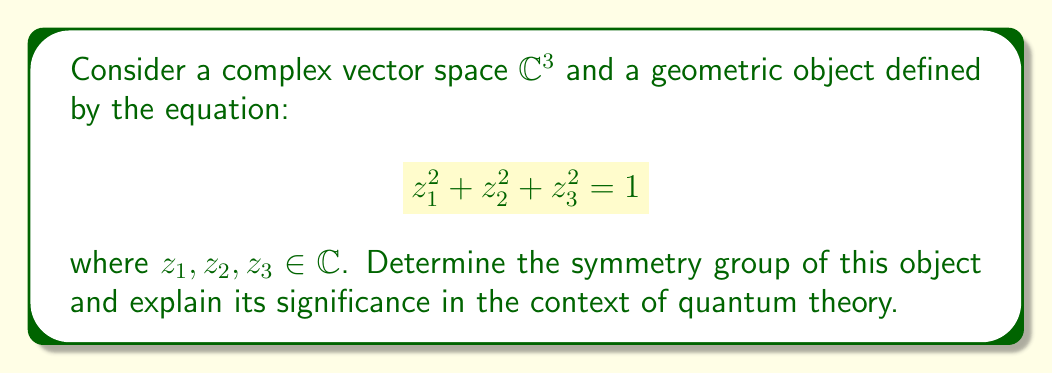Teach me how to tackle this problem. 1. Identify the equation:
   The equation $z_1^2 + z_2^2 + z_3^2 = 1$ defines a complex 2-sphere in $\mathbb{C}^3$.

2. Analyze symmetries:
   a) Rotational symmetry: The equation is invariant under rotations in $\mathbb{C}^3$, represented by the special orthogonal group $SO(3, \mathbb{C})$.
   b) Reflection symmetry: The equation is also invariant under reflections, which together with rotations form the orthogonal group $O(3, \mathbb{C})$.

3. Identify the symmetry group:
   The full symmetry group is $O(3, \mathbb{C})$.

4. Quantum theory connection:
   a) The complex 2-sphere is isomorphic to the Bloch sphere, which represents pure qubit states in quantum mechanics.
   b) The symmetry group $O(3, \mathbb{C})$ is closely related to the $SU(2)$ group, which describes spin-1/2 particles and qubit rotations.

5. Significance in quantum theory:
   a) The symmetries of this object reflect the invariance of quantum states under certain transformations.
   b) Understanding these symmetries is crucial for analyzing quantum entanglement and designing quantum gates.
   c) The connection between the complex 2-sphere and the Bloch sphere provides a geometric interpretation of qubit states and operations.

6. Experimental relevance:
   The symmetry properties of this object can be used to predict and interpret experimental results in quantum systems, particularly in quantum computing and quantum optics experiments involving qubits.
Answer: $O(3, \mathbb{C})$ 